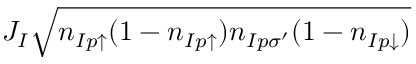Convert formula to latex. <formula><loc_0><loc_0><loc_500><loc_500>J _ { I } \sqrt { n _ { I p \uparrow } ( 1 - n _ { I p \uparrow } ) n _ { I p \sigma ^ { \prime } } ( 1 - n _ { I p \downarrow } ) }</formula> 